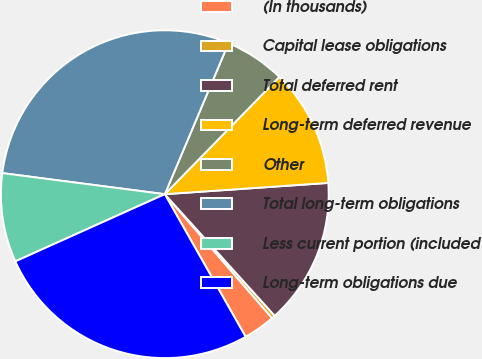<chart> <loc_0><loc_0><loc_500><loc_500><pie_chart><fcel>(In thousands)<fcel>Capital lease obligations<fcel>Total deferred rent<fcel>Long-term deferred revenue<fcel>Other<fcel>Total long-term obligations<fcel>Less current portion (included<fcel>Long-term obligations due<nl><fcel>3.15%<fcel>0.34%<fcel>14.4%<fcel>11.59%<fcel>5.96%<fcel>29.3%<fcel>8.78%<fcel>26.48%<nl></chart> 